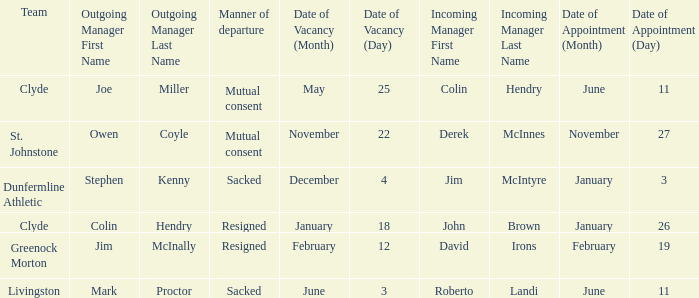I want to know the team that was sacked and date of vacancy was 4 december Dunfermline Athletic. 